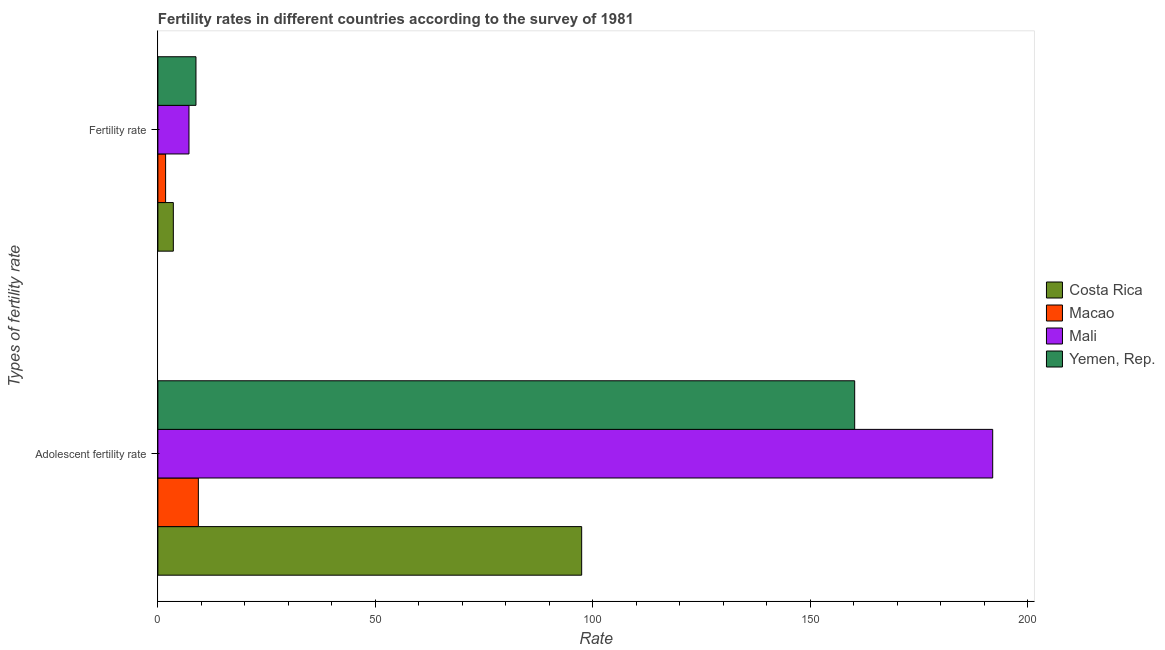Are the number of bars per tick equal to the number of legend labels?
Make the answer very short. Yes. What is the label of the 2nd group of bars from the top?
Ensure brevity in your answer.  Adolescent fertility rate. What is the fertility rate in Costa Rica?
Keep it short and to the point. 3.55. Across all countries, what is the maximum adolescent fertility rate?
Your answer should be compact. 191.96. Across all countries, what is the minimum adolescent fertility rate?
Offer a terse response. 9.31. In which country was the fertility rate maximum?
Make the answer very short. Yemen, Rep. In which country was the fertility rate minimum?
Keep it short and to the point. Macao. What is the total adolescent fertility rate in the graph?
Provide a succinct answer. 458.94. What is the difference between the fertility rate in Costa Rica and that in Yemen, Rep.?
Ensure brevity in your answer.  -5.2. What is the difference between the fertility rate in Yemen, Rep. and the adolescent fertility rate in Mali?
Provide a succinct answer. -183.21. What is the average fertility rate per country?
Give a very brief answer. 5.31. What is the difference between the fertility rate and adolescent fertility rate in Macao?
Keep it short and to the point. -7.53. What is the ratio of the adolescent fertility rate in Mali to that in Costa Rica?
Your answer should be very brief. 1.97. In how many countries, is the adolescent fertility rate greater than the average adolescent fertility rate taken over all countries?
Your answer should be compact. 2. What does the 2nd bar from the top in Fertility rate represents?
Your response must be concise. Mali. What does the 3rd bar from the bottom in Adolescent fertility rate represents?
Provide a succinct answer. Mali. How many bars are there?
Offer a very short reply. 8. Are all the bars in the graph horizontal?
Your answer should be compact. Yes. How many countries are there in the graph?
Provide a short and direct response. 4. What is the difference between two consecutive major ticks on the X-axis?
Offer a very short reply. 50. Does the graph contain grids?
Your answer should be compact. No. Where does the legend appear in the graph?
Your response must be concise. Center right. How many legend labels are there?
Your answer should be very brief. 4. What is the title of the graph?
Your response must be concise. Fertility rates in different countries according to the survey of 1981. What is the label or title of the X-axis?
Provide a succinct answer. Rate. What is the label or title of the Y-axis?
Give a very brief answer. Types of fertility rate. What is the Rate of Costa Rica in Adolescent fertility rate?
Provide a short and direct response. 97.45. What is the Rate of Macao in Adolescent fertility rate?
Provide a short and direct response. 9.31. What is the Rate in Mali in Adolescent fertility rate?
Keep it short and to the point. 191.96. What is the Rate in Yemen, Rep. in Adolescent fertility rate?
Your answer should be very brief. 160.23. What is the Rate of Costa Rica in Fertility rate?
Your response must be concise. 3.55. What is the Rate in Macao in Fertility rate?
Provide a succinct answer. 1.78. What is the Rate in Mali in Fertility rate?
Ensure brevity in your answer.  7.15. What is the Rate in Yemen, Rep. in Fertility rate?
Give a very brief answer. 8.76. Across all Types of fertility rate, what is the maximum Rate in Costa Rica?
Keep it short and to the point. 97.45. Across all Types of fertility rate, what is the maximum Rate of Macao?
Your response must be concise. 9.31. Across all Types of fertility rate, what is the maximum Rate of Mali?
Your answer should be very brief. 191.96. Across all Types of fertility rate, what is the maximum Rate of Yemen, Rep.?
Offer a terse response. 160.23. Across all Types of fertility rate, what is the minimum Rate in Costa Rica?
Offer a very short reply. 3.55. Across all Types of fertility rate, what is the minimum Rate of Macao?
Offer a very short reply. 1.78. Across all Types of fertility rate, what is the minimum Rate in Mali?
Keep it short and to the point. 7.15. Across all Types of fertility rate, what is the minimum Rate in Yemen, Rep.?
Keep it short and to the point. 8.76. What is the total Rate of Costa Rica in the graph?
Keep it short and to the point. 101. What is the total Rate in Macao in the graph?
Your answer should be very brief. 11.08. What is the total Rate in Mali in the graph?
Your response must be concise. 199.11. What is the total Rate in Yemen, Rep. in the graph?
Your answer should be compact. 168.98. What is the difference between the Rate in Costa Rica in Adolescent fertility rate and that in Fertility rate?
Your answer should be compact. 93.9. What is the difference between the Rate of Macao in Adolescent fertility rate and that in Fertility rate?
Give a very brief answer. 7.53. What is the difference between the Rate in Mali in Adolescent fertility rate and that in Fertility rate?
Your answer should be very brief. 184.81. What is the difference between the Rate in Yemen, Rep. in Adolescent fertility rate and that in Fertility rate?
Offer a very short reply. 151.47. What is the difference between the Rate of Costa Rica in Adolescent fertility rate and the Rate of Macao in Fertility rate?
Your answer should be compact. 95.67. What is the difference between the Rate in Costa Rica in Adolescent fertility rate and the Rate in Mali in Fertility rate?
Offer a terse response. 90.3. What is the difference between the Rate in Costa Rica in Adolescent fertility rate and the Rate in Yemen, Rep. in Fertility rate?
Ensure brevity in your answer.  88.69. What is the difference between the Rate of Macao in Adolescent fertility rate and the Rate of Mali in Fertility rate?
Your answer should be compact. 2.16. What is the difference between the Rate in Macao in Adolescent fertility rate and the Rate in Yemen, Rep. in Fertility rate?
Make the answer very short. 0.55. What is the difference between the Rate of Mali in Adolescent fertility rate and the Rate of Yemen, Rep. in Fertility rate?
Offer a terse response. 183.21. What is the average Rate of Costa Rica per Types of fertility rate?
Keep it short and to the point. 50.5. What is the average Rate of Macao per Types of fertility rate?
Give a very brief answer. 5.54. What is the average Rate of Mali per Types of fertility rate?
Your response must be concise. 99.56. What is the average Rate of Yemen, Rep. per Types of fertility rate?
Make the answer very short. 84.49. What is the difference between the Rate in Costa Rica and Rate in Macao in Adolescent fertility rate?
Offer a very short reply. 88.14. What is the difference between the Rate of Costa Rica and Rate of Mali in Adolescent fertility rate?
Provide a succinct answer. -94.52. What is the difference between the Rate in Costa Rica and Rate in Yemen, Rep. in Adolescent fertility rate?
Your response must be concise. -62.78. What is the difference between the Rate in Macao and Rate in Mali in Adolescent fertility rate?
Your answer should be very brief. -182.66. What is the difference between the Rate in Macao and Rate in Yemen, Rep. in Adolescent fertility rate?
Provide a succinct answer. -150.92. What is the difference between the Rate in Mali and Rate in Yemen, Rep. in Adolescent fertility rate?
Give a very brief answer. 31.74. What is the difference between the Rate of Costa Rica and Rate of Macao in Fertility rate?
Provide a succinct answer. 1.77. What is the difference between the Rate in Costa Rica and Rate in Mali in Fertility rate?
Offer a very short reply. -3.6. What is the difference between the Rate of Costa Rica and Rate of Yemen, Rep. in Fertility rate?
Offer a terse response. -5.2. What is the difference between the Rate of Macao and Rate of Mali in Fertility rate?
Keep it short and to the point. -5.37. What is the difference between the Rate in Macao and Rate in Yemen, Rep. in Fertility rate?
Give a very brief answer. -6.98. What is the difference between the Rate of Mali and Rate of Yemen, Rep. in Fertility rate?
Provide a short and direct response. -1.61. What is the ratio of the Rate in Costa Rica in Adolescent fertility rate to that in Fertility rate?
Your answer should be very brief. 27.43. What is the ratio of the Rate of Macao in Adolescent fertility rate to that in Fertility rate?
Your response must be concise. 5.24. What is the ratio of the Rate of Mali in Adolescent fertility rate to that in Fertility rate?
Provide a short and direct response. 26.85. What is the ratio of the Rate in Yemen, Rep. in Adolescent fertility rate to that in Fertility rate?
Your answer should be very brief. 18.3. What is the difference between the highest and the second highest Rate in Costa Rica?
Keep it short and to the point. 93.9. What is the difference between the highest and the second highest Rate of Macao?
Ensure brevity in your answer.  7.53. What is the difference between the highest and the second highest Rate of Mali?
Your response must be concise. 184.81. What is the difference between the highest and the second highest Rate of Yemen, Rep.?
Provide a succinct answer. 151.47. What is the difference between the highest and the lowest Rate of Costa Rica?
Your response must be concise. 93.9. What is the difference between the highest and the lowest Rate in Macao?
Offer a very short reply. 7.53. What is the difference between the highest and the lowest Rate in Mali?
Your response must be concise. 184.81. What is the difference between the highest and the lowest Rate in Yemen, Rep.?
Keep it short and to the point. 151.47. 